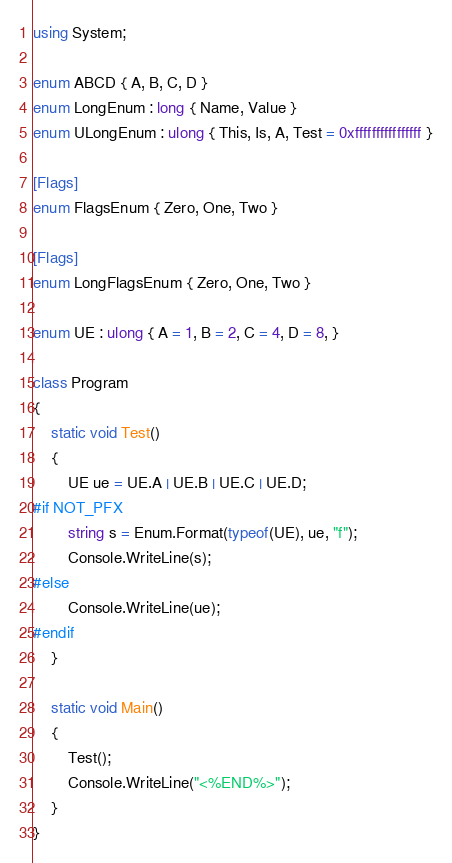Convert code to text. <code><loc_0><loc_0><loc_500><loc_500><_C#_>using System;

enum ABCD { A, B, C, D }
enum LongEnum : long { Name, Value }
enum ULongEnum : ulong { This, Is, A, Test = 0xffffffffffffffff }

[Flags]
enum FlagsEnum { Zero, One, Two }

[Flags]
enum LongFlagsEnum { Zero, One, Two }

enum UE : ulong { A = 1, B = 2, C = 4, D = 8, }

class Program
{
    static void Test()
    {
        UE ue = UE.A | UE.B | UE.C | UE.D;
#if NOT_PFX
        string s = Enum.Format(typeof(UE), ue, "f");
        Console.WriteLine(s);
#else
        Console.WriteLine(ue);
#endif
    }

    static void Main()
    {
        Test();
        Console.WriteLine("<%END%>");
    }
}</code> 